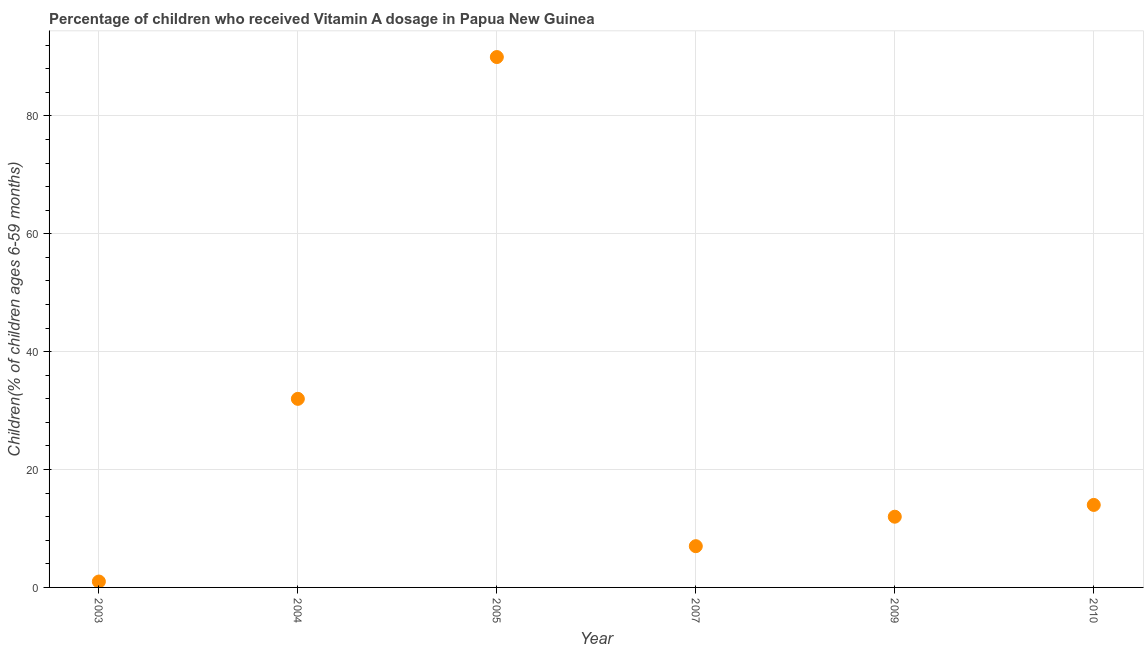What is the vitamin a supplementation coverage rate in 2004?
Ensure brevity in your answer.  32. Across all years, what is the maximum vitamin a supplementation coverage rate?
Provide a succinct answer. 90. Across all years, what is the minimum vitamin a supplementation coverage rate?
Give a very brief answer. 1. In which year was the vitamin a supplementation coverage rate maximum?
Your response must be concise. 2005. In which year was the vitamin a supplementation coverage rate minimum?
Your answer should be very brief. 2003. What is the sum of the vitamin a supplementation coverage rate?
Offer a terse response. 156. What is the difference between the vitamin a supplementation coverage rate in 2007 and 2009?
Offer a terse response. -5. What is the median vitamin a supplementation coverage rate?
Ensure brevity in your answer.  13. What is the ratio of the vitamin a supplementation coverage rate in 2003 to that in 2009?
Make the answer very short. 0.08. What is the difference between the highest and the second highest vitamin a supplementation coverage rate?
Give a very brief answer. 58. What is the difference between the highest and the lowest vitamin a supplementation coverage rate?
Offer a terse response. 89. How many dotlines are there?
Your answer should be very brief. 1. How many years are there in the graph?
Ensure brevity in your answer.  6. Are the values on the major ticks of Y-axis written in scientific E-notation?
Provide a short and direct response. No. Does the graph contain any zero values?
Make the answer very short. No. What is the title of the graph?
Give a very brief answer. Percentage of children who received Vitamin A dosage in Papua New Guinea. What is the label or title of the X-axis?
Give a very brief answer. Year. What is the label or title of the Y-axis?
Provide a short and direct response. Children(% of children ages 6-59 months). What is the Children(% of children ages 6-59 months) in 2003?
Your answer should be compact. 1. What is the Children(% of children ages 6-59 months) in 2004?
Your response must be concise. 32. What is the Children(% of children ages 6-59 months) in 2007?
Your answer should be very brief. 7. What is the difference between the Children(% of children ages 6-59 months) in 2003 and 2004?
Provide a short and direct response. -31. What is the difference between the Children(% of children ages 6-59 months) in 2003 and 2005?
Your answer should be very brief. -89. What is the difference between the Children(% of children ages 6-59 months) in 2004 and 2005?
Your answer should be compact. -58. What is the difference between the Children(% of children ages 6-59 months) in 2004 and 2007?
Your response must be concise. 25. What is the difference between the Children(% of children ages 6-59 months) in 2004 and 2010?
Keep it short and to the point. 18. What is the difference between the Children(% of children ages 6-59 months) in 2007 and 2009?
Provide a succinct answer. -5. What is the difference between the Children(% of children ages 6-59 months) in 2007 and 2010?
Provide a short and direct response. -7. What is the ratio of the Children(% of children ages 6-59 months) in 2003 to that in 2004?
Offer a terse response. 0.03. What is the ratio of the Children(% of children ages 6-59 months) in 2003 to that in 2005?
Provide a succinct answer. 0.01. What is the ratio of the Children(% of children ages 6-59 months) in 2003 to that in 2007?
Make the answer very short. 0.14. What is the ratio of the Children(% of children ages 6-59 months) in 2003 to that in 2009?
Your answer should be very brief. 0.08. What is the ratio of the Children(% of children ages 6-59 months) in 2003 to that in 2010?
Provide a succinct answer. 0.07. What is the ratio of the Children(% of children ages 6-59 months) in 2004 to that in 2005?
Your response must be concise. 0.36. What is the ratio of the Children(% of children ages 6-59 months) in 2004 to that in 2007?
Make the answer very short. 4.57. What is the ratio of the Children(% of children ages 6-59 months) in 2004 to that in 2009?
Ensure brevity in your answer.  2.67. What is the ratio of the Children(% of children ages 6-59 months) in 2004 to that in 2010?
Your answer should be compact. 2.29. What is the ratio of the Children(% of children ages 6-59 months) in 2005 to that in 2007?
Your answer should be very brief. 12.86. What is the ratio of the Children(% of children ages 6-59 months) in 2005 to that in 2009?
Your answer should be very brief. 7.5. What is the ratio of the Children(% of children ages 6-59 months) in 2005 to that in 2010?
Make the answer very short. 6.43. What is the ratio of the Children(% of children ages 6-59 months) in 2007 to that in 2009?
Your answer should be very brief. 0.58. What is the ratio of the Children(% of children ages 6-59 months) in 2009 to that in 2010?
Offer a very short reply. 0.86. 